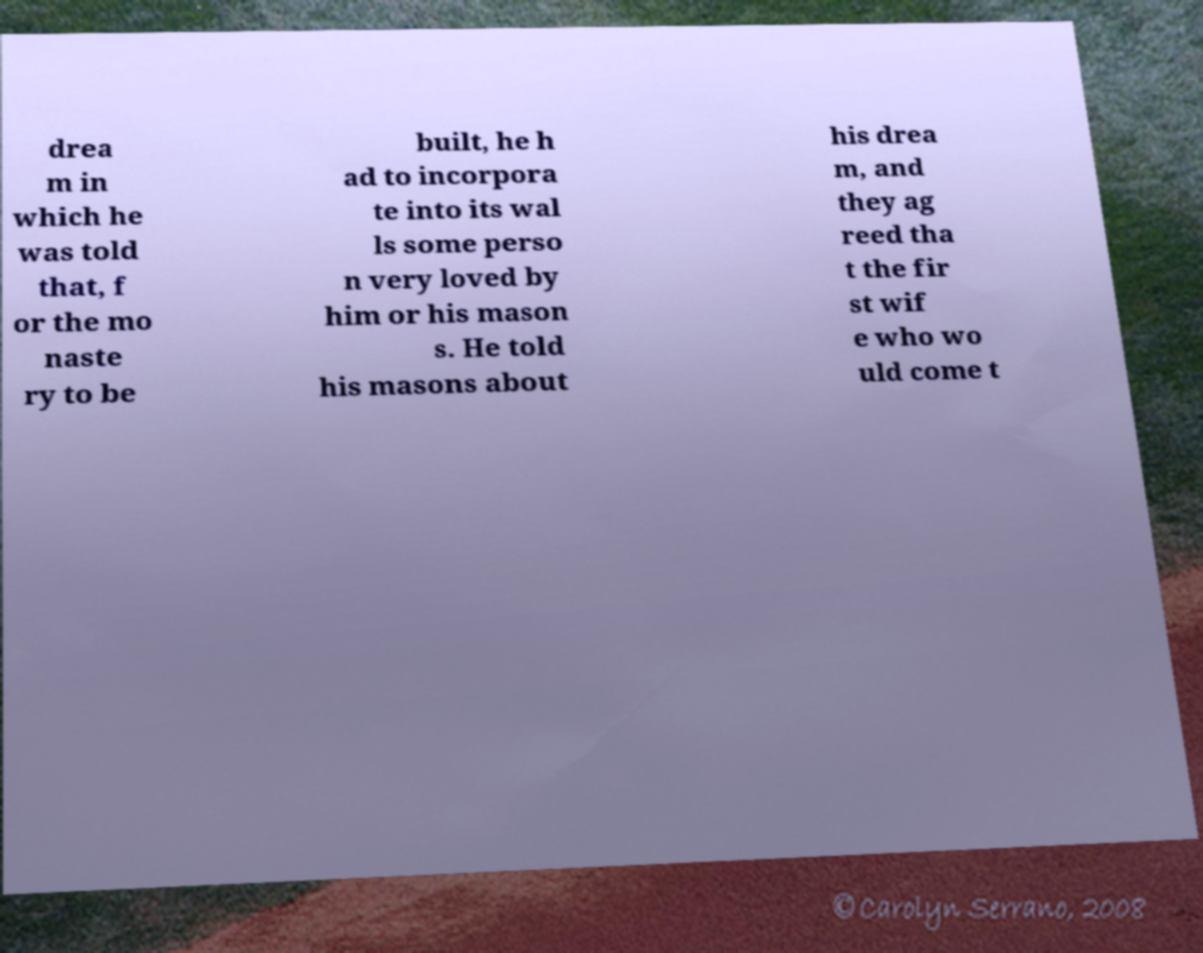Please read and relay the text visible in this image. What does it say? drea m in which he was told that, f or the mo naste ry to be built, he h ad to incorpora te into its wal ls some perso n very loved by him or his mason s. He told his masons about his drea m, and they ag reed tha t the fir st wif e who wo uld come t 